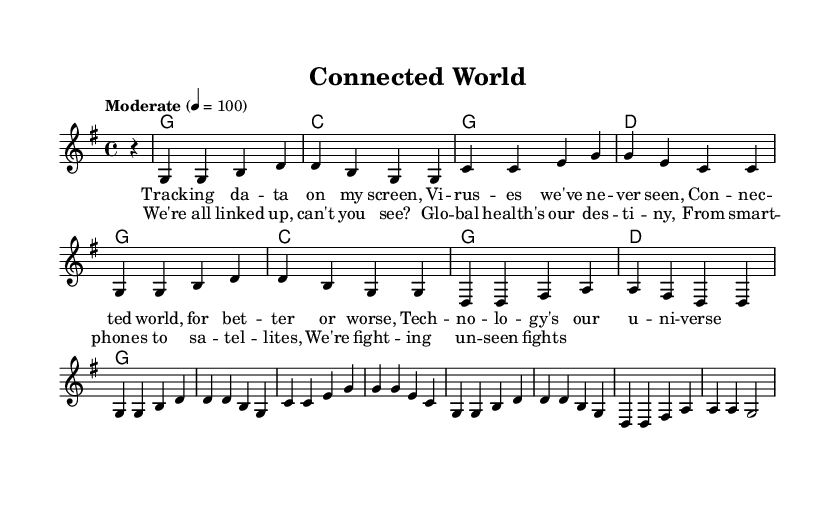What is the key signature of this music? The key signature is G major, which has one sharp (F#). This can be identified by looking at the key signature section on the left side of the first staff.
Answer: G major What is the time signature of this music? The time signature is 4/4, indicated at the beginning of the score, which means there are four beats in each measure and the quarter note gets one beat.
Answer: 4/4 What is the tempo of this piece? The tempo marking is "Moderate" with a metronome marking of 100 beats per minute. This information is typically found above the staff near the beginning of the piece.
Answer: 100 How many measures are there in the chorus? The chorus comprises eight measures. By counting the measures visually in the corresponding section of the sheet music, one can see that it spans from the start of the lyrics to the end of the musical notation in that section.
Answer: Eight What is the tonality of the piece? The tonality is major as indicated by the key signature (G major) and the overall sound and chord progressions used in the piece. This conclusion is drawn from the bright sound characteristic of major keys and the use of major chords.
Answer: Major What is the first word of the second verse? The first word of the second verse is "We're," which is seen at the beginning of the corresponding lyrics section of the sheet music.
Answer: We're What musical concept is emphasized in the lyrics of this song? The lyrics emphasize global connectivity through technology, as seen in phrases like "connected world" and "global health's our destiny," showing the lyrical focus on how technology links people for health and wellness.
Answer: Global connectivity 